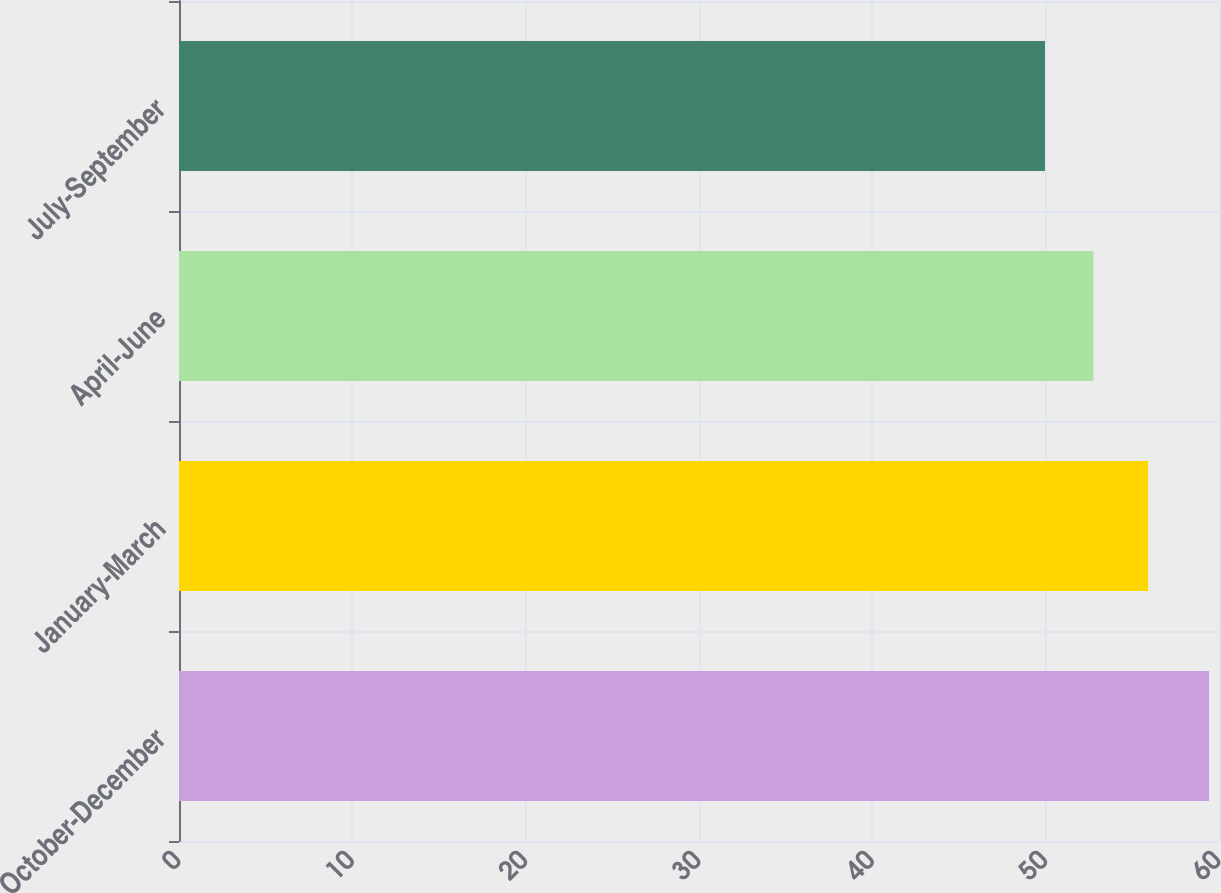<chart> <loc_0><loc_0><loc_500><loc_500><bar_chart><fcel>October-December<fcel>January-March<fcel>April-June<fcel>July-September<nl><fcel>59.43<fcel>55.91<fcel>52.76<fcel>49.96<nl></chart> 